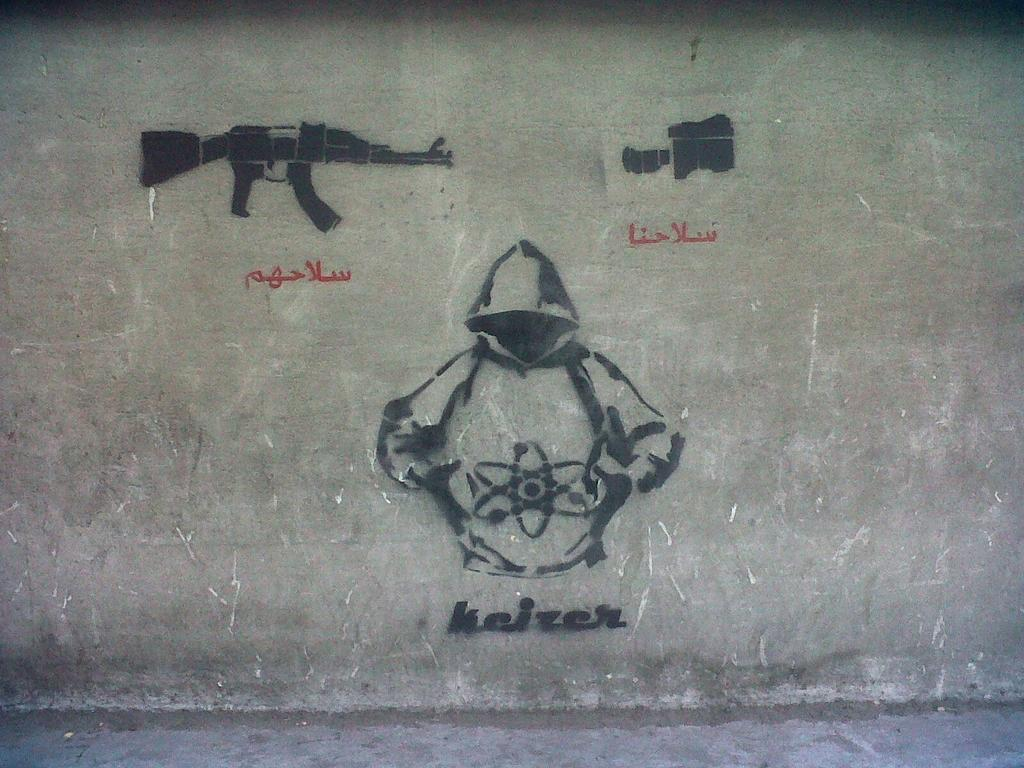What can be seen on the wall in the image? There are images and text on the wall. Can you describe the images on the wall? Unfortunately, the specific images on the wall cannot be described without more information. What does the text on the wall say? The content of the text on the wall cannot be determined without more information. How many stitches are visible on the wall in the image? There are no stitches visible on the wall in the image. What is the current temperature in the room depicted in the image? The current temperature cannot be determined from the image. 